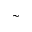Convert formula to latex. <formula><loc_0><loc_0><loc_500><loc_500>\sim</formula> 